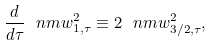<formula> <loc_0><loc_0><loc_500><loc_500>\frac { d } { d \tau } \ n m { w } ^ { 2 } _ { 1 , \tau } \equiv 2 \ n m { w } ^ { 2 } _ { 3 / 2 , \tau } ,</formula> 